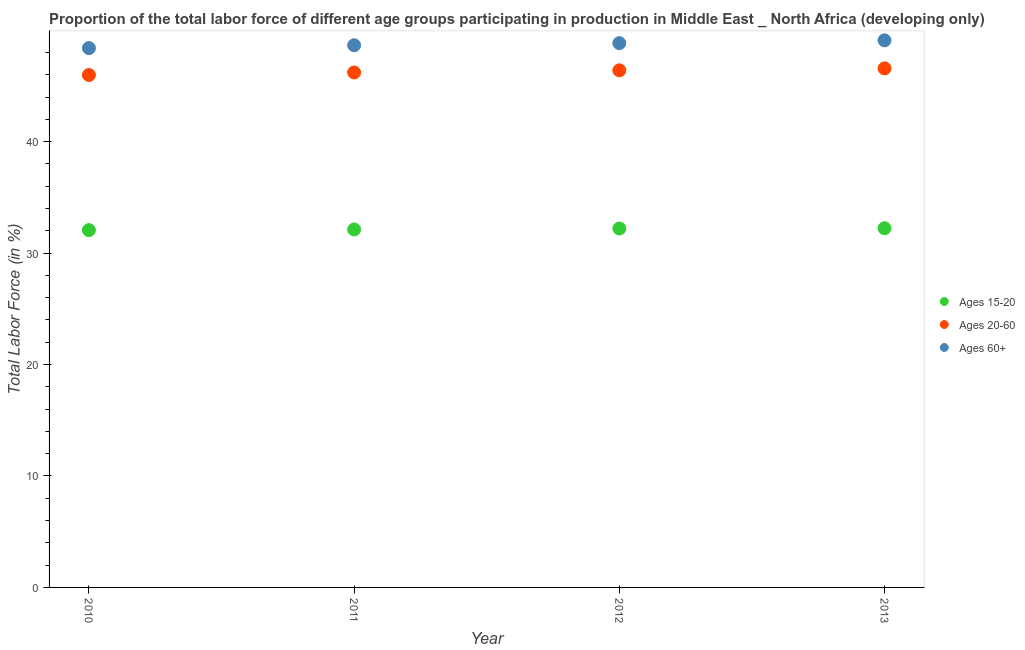What is the percentage of labor force within the age group 15-20 in 2012?
Your answer should be very brief. 32.21. Across all years, what is the maximum percentage of labor force within the age group 15-20?
Your answer should be compact. 32.23. Across all years, what is the minimum percentage of labor force within the age group 15-20?
Offer a terse response. 32.06. In which year was the percentage of labor force above age 60 minimum?
Keep it short and to the point. 2010. What is the total percentage of labor force within the age group 15-20 in the graph?
Provide a short and direct response. 128.63. What is the difference between the percentage of labor force within the age group 15-20 in 2011 and that in 2012?
Give a very brief answer. -0.08. What is the difference between the percentage of labor force within the age group 15-20 in 2011 and the percentage of labor force within the age group 20-60 in 2012?
Your answer should be compact. -14.28. What is the average percentage of labor force within the age group 15-20 per year?
Provide a short and direct response. 32.16. In the year 2013, what is the difference between the percentage of labor force within the age group 15-20 and percentage of labor force above age 60?
Make the answer very short. -16.86. What is the ratio of the percentage of labor force within the age group 15-20 in 2011 to that in 2012?
Provide a short and direct response. 1. Is the difference between the percentage of labor force within the age group 15-20 in 2012 and 2013 greater than the difference between the percentage of labor force within the age group 20-60 in 2012 and 2013?
Offer a very short reply. Yes. What is the difference between the highest and the second highest percentage of labor force within the age group 15-20?
Provide a succinct answer. 0.02. What is the difference between the highest and the lowest percentage of labor force above age 60?
Provide a short and direct response. 0.7. In how many years, is the percentage of labor force above age 60 greater than the average percentage of labor force above age 60 taken over all years?
Give a very brief answer. 2. Is the sum of the percentage of labor force above age 60 in 2010 and 2012 greater than the maximum percentage of labor force within the age group 15-20 across all years?
Offer a terse response. Yes. Is it the case that in every year, the sum of the percentage of labor force within the age group 15-20 and percentage of labor force within the age group 20-60 is greater than the percentage of labor force above age 60?
Offer a terse response. Yes. What is the difference between two consecutive major ticks on the Y-axis?
Keep it short and to the point. 10. Are the values on the major ticks of Y-axis written in scientific E-notation?
Your answer should be very brief. No. Does the graph contain any zero values?
Make the answer very short. No. Does the graph contain grids?
Give a very brief answer. No. What is the title of the graph?
Give a very brief answer. Proportion of the total labor force of different age groups participating in production in Middle East _ North Africa (developing only). Does "Infant(female)" appear as one of the legend labels in the graph?
Your response must be concise. No. What is the Total Labor Force (in %) of Ages 15-20 in 2010?
Offer a very short reply. 32.06. What is the Total Labor Force (in %) of Ages 20-60 in 2010?
Your answer should be very brief. 45.98. What is the Total Labor Force (in %) of Ages 60+ in 2010?
Your answer should be compact. 48.4. What is the Total Labor Force (in %) in Ages 15-20 in 2011?
Provide a short and direct response. 32.12. What is the Total Labor Force (in %) of Ages 20-60 in 2011?
Your answer should be very brief. 46.21. What is the Total Labor Force (in %) in Ages 60+ in 2011?
Provide a short and direct response. 48.65. What is the Total Labor Force (in %) in Ages 15-20 in 2012?
Your answer should be compact. 32.21. What is the Total Labor Force (in %) in Ages 20-60 in 2012?
Ensure brevity in your answer.  46.4. What is the Total Labor Force (in %) of Ages 60+ in 2012?
Offer a very short reply. 48.84. What is the Total Labor Force (in %) in Ages 15-20 in 2013?
Ensure brevity in your answer.  32.23. What is the Total Labor Force (in %) of Ages 20-60 in 2013?
Ensure brevity in your answer.  46.58. What is the Total Labor Force (in %) in Ages 60+ in 2013?
Make the answer very short. 49.1. Across all years, what is the maximum Total Labor Force (in %) of Ages 15-20?
Offer a terse response. 32.23. Across all years, what is the maximum Total Labor Force (in %) in Ages 20-60?
Make the answer very short. 46.58. Across all years, what is the maximum Total Labor Force (in %) in Ages 60+?
Provide a succinct answer. 49.1. Across all years, what is the minimum Total Labor Force (in %) in Ages 15-20?
Provide a short and direct response. 32.06. Across all years, what is the minimum Total Labor Force (in %) in Ages 20-60?
Your response must be concise. 45.98. Across all years, what is the minimum Total Labor Force (in %) in Ages 60+?
Provide a short and direct response. 48.4. What is the total Total Labor Force (in %) of Ages 15-20 in the graph?
Your answer should be very brief. 128.63. What is the total Total Labor Force (in %) in Ages 20-60 in the graph?
Offer a terse response. 185.17. What is the total Total Labor Force (in %) in Ages 60+ in the graph?
Your answer should be compact. 194.99. What is the difference between the Total Labor Force (in %) in Ages 15-20 in 2010 and that in 2011?
Ensure brevity in your answer.  -0.06. What is the difference between the Total Labor Force (in %) of Ages 20-60 in 2010 and that in 2011?
Your answer should be compact. -0.22. What is the difference between the Total Labor Force (in %) in Ages 60+ in 2010 and that in 2011?
Your response must be concise. -0.26. What is the difference between the Total Labor Force (in %) of Ages 15-20 in 2010 and that in 2012?
Offer a very short reply. -0.14. What is the difference between the Total Labor Force (in %) in Ages 20-60 in 2010 and that in 2012?
Give a very brief answer. -0.42. What is the difference between the Total Labor Force (in %) of Ages 60+ in 2010 and that in 2012?
Your answer should be compact. -0.44. What is the difference between the Total Labor Force (in %) of Ages 15-20 in 2010 and that in 2013?
Give a very brief answer. -0.17. What is the difference between the Total Labor Force (in %) of Ages 20-60 in 2010 and that in 2013?
Your response must be concise. -0.59. What is the difference between the Total Labor Force (in %) in Ages 60+ in 2010 and that in 2013?
Give a very brief answer. -0.7. What is the difference between the Total Labor Force (in %) in Ages 15-20 in 2011 and that in 2012?
Your response must be concise. -0.08. What is the difference between the Total Labor Force (in %) of Ages 20-60 in 2011 and that in 2012?
Make the answer very short. -0.19. What is the difference between the Total Labor Force (in %) in Ages 60+ in 2011 and that in 2012?
Ensure brevity in your answer.  -0.19. What is the difference between the Total Labor Force (in %) of Ages 15-20 in 2011 and that in 2013?
Give a very brief answer. -0.11. What is the difference between the Total Labor Force (in %) of Ages 20-60 in 2011 and that in 2013?
Make the answer very short. -0.37. What is the difference between the Total Labor Force (in %) of Ages 60+ in 2011 and that in 2013?
Provide a succinct answer. -0.44. What is the difference between the Total Labor Force (in %) in Ages 15-20 in 2012 and that in 2013?
Make the answer very short. -0.02. What is the difference between the Total Labor Force (in %) of Ages 20-60 in 2012 and that in 2013?
Make the answer very short. -0.18. What is the difference between the Total Labor Force (in %) in Ages 60+ in 2012 and that in 2013?
Offer a very short reply. -0.25. What is the difference between the Total Labor Force (in %) of Ages 15-20 in 2010 and the Total Labor Force (in %) of Ages 20-60 in 2011?
Your response must be concise. -14.14. What is the difference between the Total Labor Force (in %) in Ages 15-20 in 2010 and the Total Labor Force (in %) in Ages 60+ in 2011?
Your answer should be compact. -16.59. What is the difference between the Total Labor Force (in %) in Ages 20-60 in 2010 and the Total Labor Force (in %) in Ages 60+ in 2011?
Your response must be concise. -2.67. What is the difference between the Total Labor Force (in %) in Ages 15-20 in 2010 and the Total Labor Force (in %) in Ages 20-60 in 2012?
Provide a succinct answer. -14.34. What is the difference between the Total Labor Force (in %) of Ages 15-20 in 2010 and the Total Labor Force (in %) of Ages 60+ in 2012?
Make the answer very short. -16.78. What is the difference between the Total Labor Force (in %) of Ages 20-60 in 2010 and the Total Labor Force (in %) of Ages 60+ in 2012?
Ensure brevity in your answer.  -2.86. What is the difference between the Total Labor Force (in %) in Ages 15-20 in 2010 and the Total Labor Force (in %) in Ages 20-60 in 2013?
Your response must be concise. -14.52. What is the difference between the Total Labor Force (in %) in Ages 15-20 in 2010 and the Total Labor Force (in %) in Ages 60+ in 2013?
Your answer should be compact. -17.03. What is the difference between the Total Labor Force (in %) in Ages 20-60 in 2010 and the Total Labor Force (in %) in Ages 60+ in 2013?
Offer a very short reply. -3.11. What is the difference between the Total Labor Force (in %) of Ages 15-20 in 2011 and the Total Labor Force (in %) of Ages 20-60 in 2012?
Ensure brevity in your answer.  -14.28. What is the difference between the Total Labor Force (in %) of Ages 15-20 in 2011 and the Total Labor Force (in %) of Ages 60+ in 2012?
Ensure brevity in your answer.  -16.72. What is the difference between the Total Labor Force (in %) in Ages 20-60 in 2011 and the Total Labor Force (in %) in Ages 60+ in 2012?
Your answer should be compact. -2.63. What is the difference between the Total Labor Force (in %) in Ages 15-20 in 2011 and the Total Labor Force (in %) in Ages 20-60 in 2013?
Give a very brief answer. -14.46. What is the difference between the Total Labor Force (in %) of Ages 15-20 in 2011 and the Total Labor Force (in %) of Ages 60+ in 2013?
Make the answer very short. -16.97. What is the difference between the Total Labor Force (in %) in Ages 20-60 in 2011 and the Total Labor Force (in %) in Ages 60+ in 2013?
Offer a terse response. -2.89. What is the difference between the Total Labor Force (in %) in Ages 15-20 in 2012 and the Total Labor Force (in %) in Ages 20-60 in 2013?
Your answer should be very brief. -14.37. What is the difference between the Total Labor Force (in %) of Ages 15-20 in 2012 and the Total Labor Force (in %) of Ages 60+ in 2013?
Provide a succinct answer. -16.89. What is the difference between the Total Labor Force (in %) of Ages 20-60 in 2012 and the Total Labor Force (in %) of Ages 60+ in 2013?
Offer a terse response. -2.69. What is the average Total Labor Force (in %) in Ages 15-20 per year?
Offer a very short reply. 32.16. What is the average Total Labor Force (in %) in Ages 20-60 per year?
Your answer should be very brief. 46.29. What is the average Total Labor Force (in %) in Ages 60+ per year?
Provide a succinct answer. 48.75. In the year 2010, what is the difference between the Total Labor Force (in %) in Ages 15-20 and Total Labor Force (in %) in Ages 20-60?
Give a very brief answer. -13.92. In the year 2010, what is the difference between the Total Labor Force (in %) in Ages 15-20 and Total Labor Force (in %) in Ages 60+?
Offer a terse response. -16.33. In the year 2010, what is the difference between the Total Labor Force (in %) of Ages 20-60 and Total Labor Force (in %) of Ages 60+?
Your answer should be compact. -2.41. In the year 2011, what is the difference between the Total Labor Force (in %) in Ages 15-20 and Total Labor Force (in %) in Ages 20-60?
Offer a terse response. -14.09. In the year 2011, what is the difference between the Total Labor Force (in %) of Ages 15-20 and Total Labor Force (in %) of Ages 60+?
Your response must be concise. -16.53. In the year 2011, what is the difference between the Total Labor Force (in %) of Ages 20-60 and Total Labor Force (in %) of Ages 60+?
Offer a very short reply. -2.44. In the year 2012, what is the difference between the Total Labor Force (in %) in Ages 15-20 and Total Labor Force (in %) in Ages 20-60?
Your response must be concise. -14.19. In the year 2012, what is the difference between the Total Labor Force (in %) in Ages 15-20 and Total Labor Force (in %) in Ages 60+?
Your answer should be compact. -16.63. In the year 2012, what is the difference between the Total Labor Force (in %) of Ages 20-60 and Total Labor Force (in %) of Ages 60+?
Your response must be concise. -2.44. In the year 2013, what is the difference between the Total Labor Force (in %) in Ages 15-20 and Total Labor Force (in %) in Ages 20-60?
Provide a succinct answer. -14.35. In the year 2013, what is the difference between the Total Labor Force (in %) of Ages 15-20 and Total Labor Force (in %) of Ages 60+?
Offer a very short reply. -16.86. In the year 2013, what is the difference between the Total Labor Force (in %) in Ages 20-60 and Total Labor Force (in %) in Ages 60+?
Keep it short and to the point. -2.52. What is the ratio of the Total Labor Force (in %) in Ages 15-20 in 2010 to that in 2011?
Your answer should be compact. 1. What is the ratio of the Total Labor Force (in %) in Ages 20-60 in 2010 to that in 2011?
Give a very brief answer. 1. What is the ratio of the Total Labor Force (in %) of Ages 15-20 in 2010 to that in 2012?
Give a very brief answer. 1. What is the ratio of the Total Labor Force (in %) in Ages 60+ in 2010 to that in 2012?
Give a very brief answer. 0.99. What is the ratio of the Total Labor Force (in %) in Ages 15-20 in 2010 to that in 2013?
Your answer should be very brief. 0.99. What is the ratio of the Total Labor Force (in %) in Ages 20-60 in 2010 to that in 2013?
Give a very brief answer. 0.99. What is the ratio of the Total Labor Force (in %) of Ages 60+ in 2010 to that in 2013?
Your response must be concise. 0.99. What is the ratio of the Total Labor Force (in %) of Ages 60+ in 2011 to that in 2012?
Keep it short and to the point. 1. What is the ratio of the Total Labor Force (in %) in Ages 15-20 in 2011 to that in 2013?
Your response must be concise. 1. What is the ratio of the Total Labor Force (in %) in Ages 60+ in 2011 to that in 2013?
Offer a very short reply. 0.99. What is the ratio of the Total Labor Force (in %) of Ages 15-20 in 2012 to that in 2013?
Provide a short and direct response. 1. What is the ratio of the Total Labor Force (in %) in Ages 20-60 in 2012 to that in 2013?
Offer a terse response. 1. What is the difference between the highest and the second highest Total Labor Force (in %) in Ages 15-20?
Give a very brief answer. 0.02. What is the difference between the highest and the second highest Total Labor Force (in %) of Ages 20-60?
Ensure brevity in your answer.  0.18. What is the difference between the highest and the second highest Total Labor Force (in %) of Ages 60+?
Provide a succinct answer. 0.25. What is the difference between the highest and the lowest Total Labor Force (in %) in Ages 15-20?
Your answer should be very brief. 0.17. What is the difference between the highest and the lowest Total Labor Force (in %) in Ages 20-60?
Provide a succinct answer. 0.59. What is the difference between the highest and the lowest Total Labor Force (in %) in Ages 60+?
Provide a succinct answer. 0.7. 